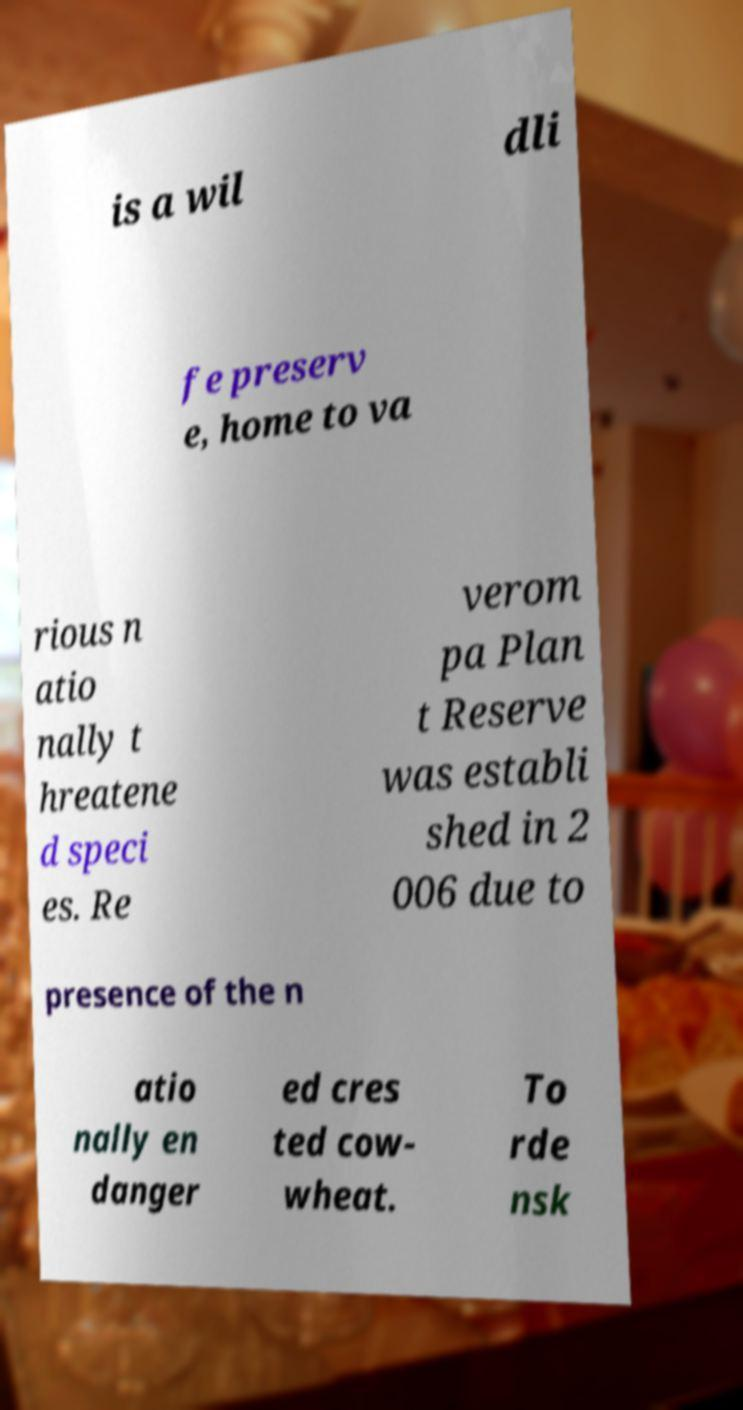There's text embedded in this image that I need extracted. Can you transcribe it verbatim? is a wil dli fe preserv e, home to va rious n atio nally t hreatene d speci es. Re verom pa Plan t Reserve was establi shed in 2 006 due to presence of the n atio nally en danger ed cres ted cow- wheat. To rde nsk 